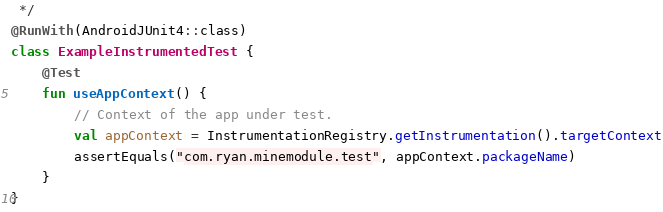Convert code to text. <code><loc_0><loc_0><loc_500><loc_500><_Kotlin_> */
@RunWith(AndroidJUnit4::class)
class ExampleInstrumentedTest {
    @Test
    fun useAppContext() {
        // Context of the app under test.
        val appContext = InstrumentationRegistry.getInstrumentation().targetContext
        assertEquals("com.ryan.minemodule.test", appContext.packageName)
    }
}
</code> 